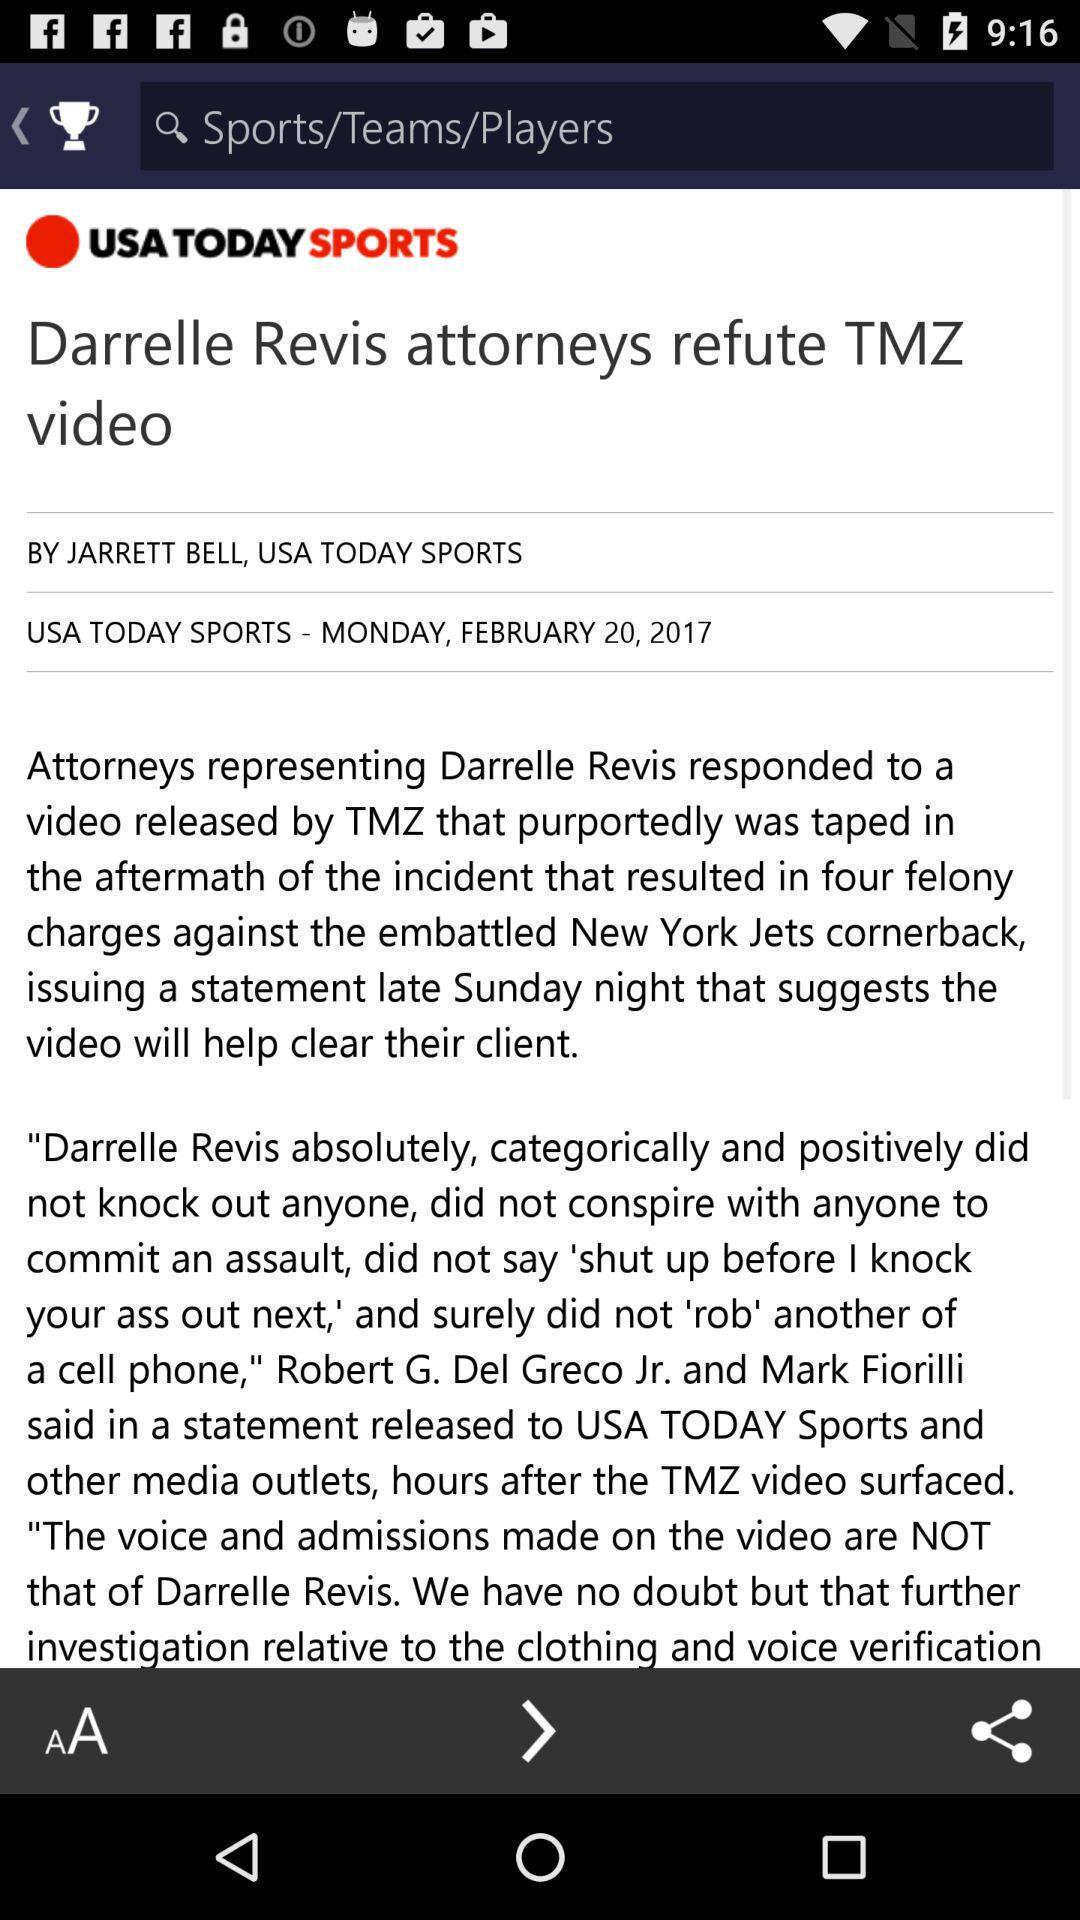What is the headline? The headline is "Darrelle Revis attorneys refute TMZ video". 